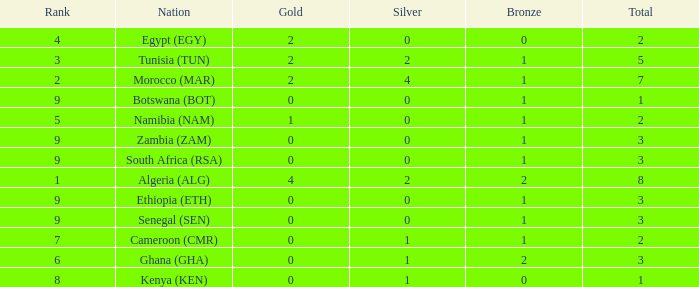What is the lowest Bronze with a Nation of egypt (egy) and with a Gold that is smaller than 2? None. 